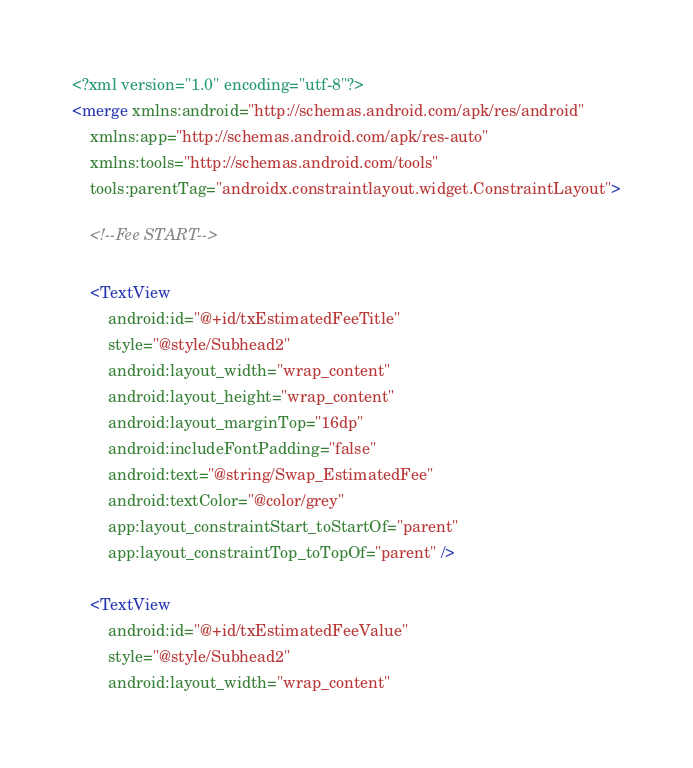Convert code to text. <code><loc_0><loc_0><loc_500><loc_500><_XML_><?xml version="1.0" encoding="utf-8"?>
<merge xmlns:android="http://schemas.android.com/apk/res/android"
    xmlns:app="http://schemas.android.com/apk/res-auto"
    xmlns:tools="http://schemas.android.com/tools"
    tools:parentTag="androidx.constraintlayout.widget.ConstraintLayout">

    <!--Fee START-->

    <TextView
        android:id="@+id/txEstimatedFeeTitle"
        style="@style/Subhead2"
        android:layout_width="wrap_content"
        android:layout_height="wrap_content"
        android:layout_marginTop="16dp"
        android:includeFontPadding="false"
        android:text="@string/Swap_EstimatedFee"
        android:textColor="@color/grey"
        app:layout_constraintStart_toStartOf="parent"
        app:layout_constraintTop_toTopOf="parent" />

    <TextView
        android:id="@+id/txEstimatedFeeValue"
        style="@style/Subhead2"
        android:layout_width="wrap_content"</code> 